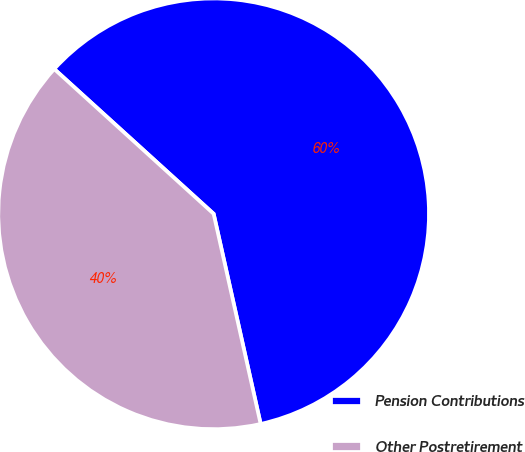Convert chart to OTSL. <chart><loc_0><loc_0><loc_500><loc_500><pie_chart><fcel>Pension Contributions<fcel>Other Postretirement<nl><fcel>59.76%<fcel>40.24%<nl></chart> 